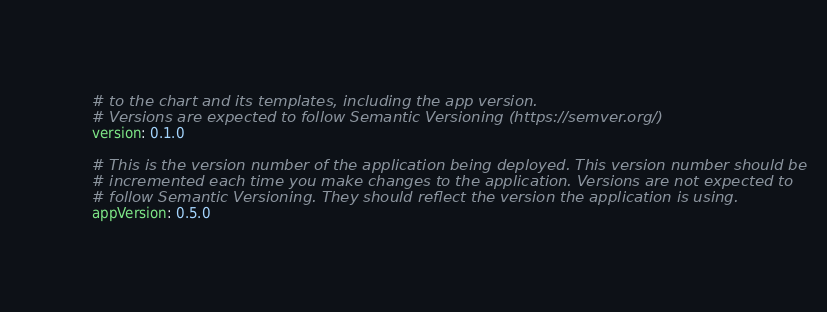<code> <loc_0><loc_0><loc_500><loc_500><_YAML_># to the chart and its templates, including the app version.
# Versions are expected to follow Semantic Versioning (https://semver.org/)
version: 0.1.0

# This is the version number of the application being deployed. This version number should be
# incremented each time you make changes to the application. Versions are not expected to
# follow Semantic Versioning. They should reflect the version the application is using.
appVersion: 0.5.0</code> 